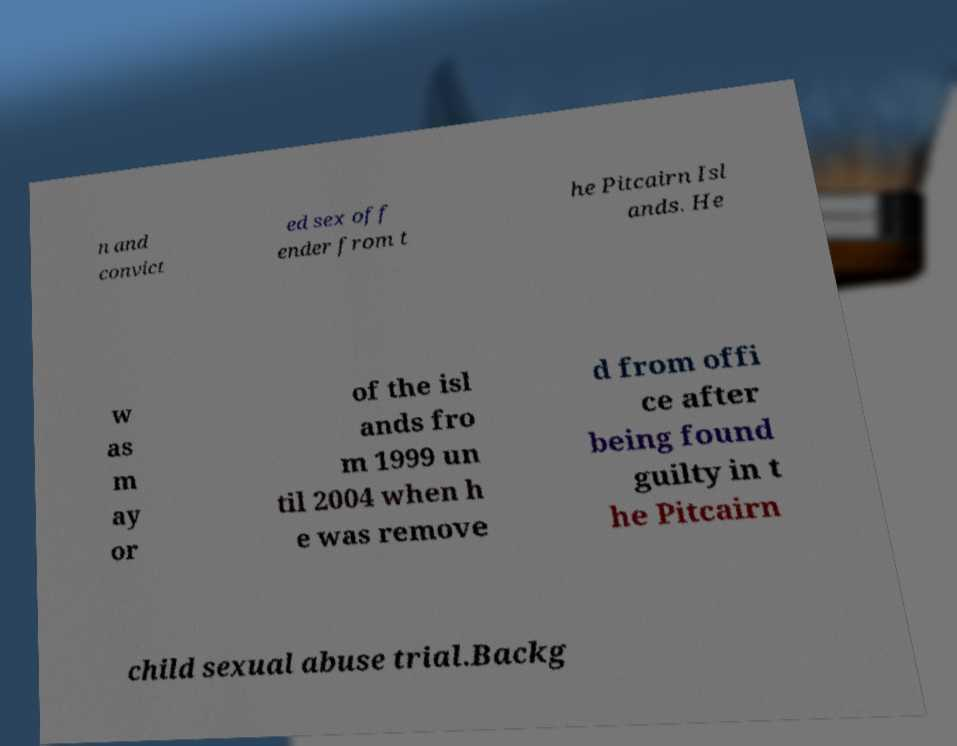There's text embedded in this image that I need extracted. Can you transcribe it verbatim? n and convict ed sex off ender from t he Pitcairn Isl ands. He w as m ay or of the isl ands fro m 1999 un til 2004 when h e was remove d from offi ce after being found guilty in t he Pitcairn child sexual abuse trial.Backg 